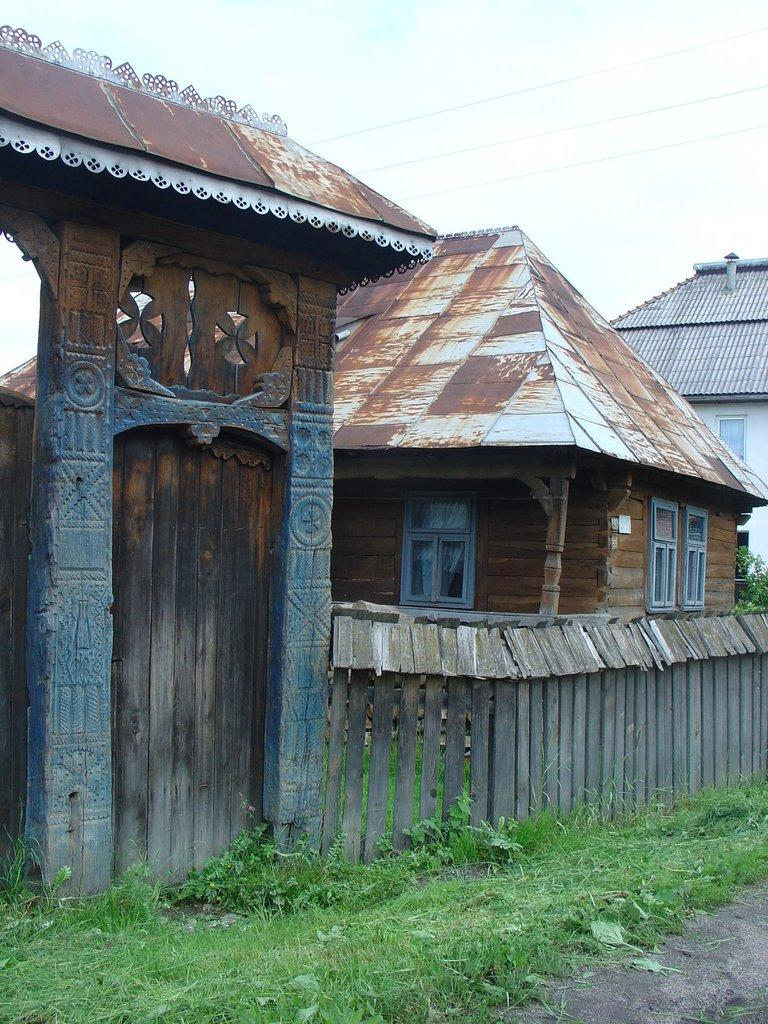What type of structures can be seen in the image? There are houses in the image. What is the purpose of the fencing in the image? The fencing in the image serves as a boundary or barrier. Can you describe a specific architectural feature in the image? There is an arch in the image. What type of landscape is visible in front of the fencing? There is grassland in front of the fencing. What type of clock is hanging on the arch in the image? There is no clock present in the image; the arch is the only architectural feature mentioned. 